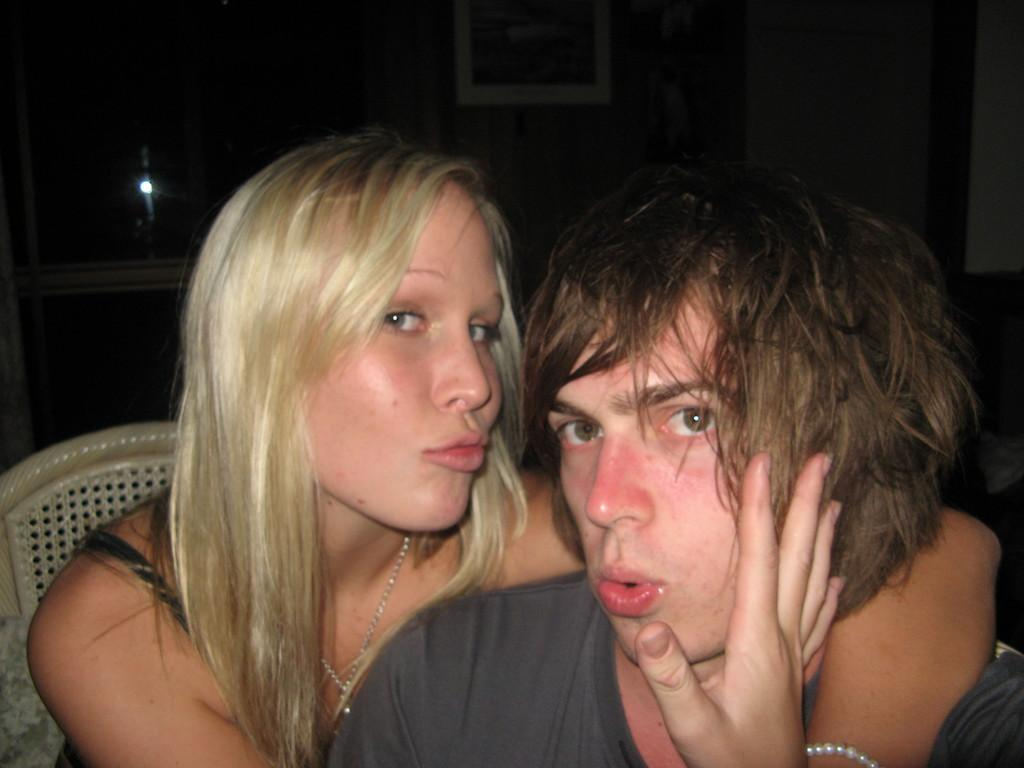How many people are in the image? There is a woman and a man in the image. What is the woman doing in the image? The information provided does not specify what the woman is doing. What is the man doing in the image? The information provided does not specify what the man is doing. What piece of furniture is in the image? There is a chair in the image. What is the lighting like in the image? There is a reflection of light in the image. What can be seen on the wall in the image? There is a picture on the wall in the image. What type of copper material is being used to make the lizards in the image? There is no copper or lizards present in the image. What is the woman holding in the can in the image? There is no can present in the image. 